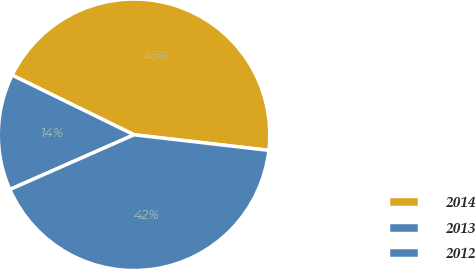Convert chart. <chart><loc_0><loc_0><loc_500><loc_500><pie_chart><fcel>2014<fcel>2013<fcel>2012<nl><fcel>44.58%<fcel>13.85%<fcel>41.56%<nl></chart> 